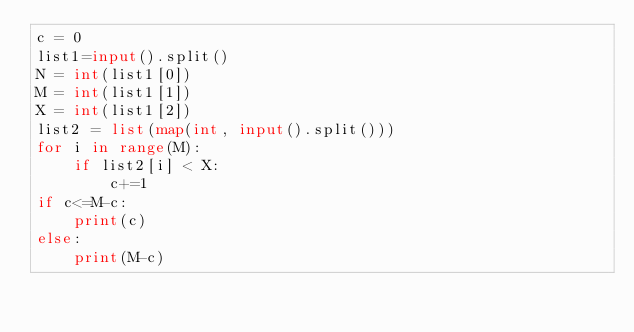<code> <loc_0><loc_0><loc_500><loc_500><_Python_>c = 0
list1=input().split()
N = int(list1[0])
M = int(list1[1])
X = int(list1[2]) 
list2 = list(map(int, input().split()))
for i in range(M):
    if list2[i] < X:
        c+=1
if c<=M-c:
    print(c)
else:
    print(M-c)</code> 